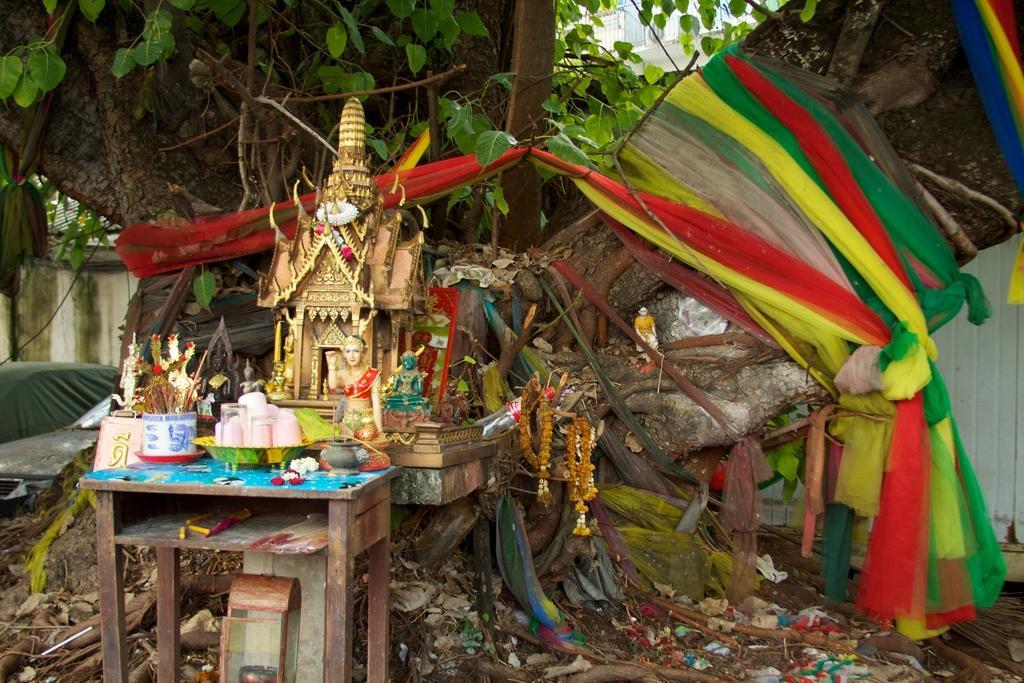Please provide a concise description of this image. In this picture there is a small table on the left side of the image, on which there are glasses, it seems to be a model of a temple in the image and there is a tree and a wall in the background area of the image, on which there are colorful clothes and there is a building at the top side of the image, there are sticks and wrappers at the bottom side of the image. 